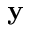Convert formula to latex. <formula><loc_0><loc_0><loc_500><loc_500>y</formula> 